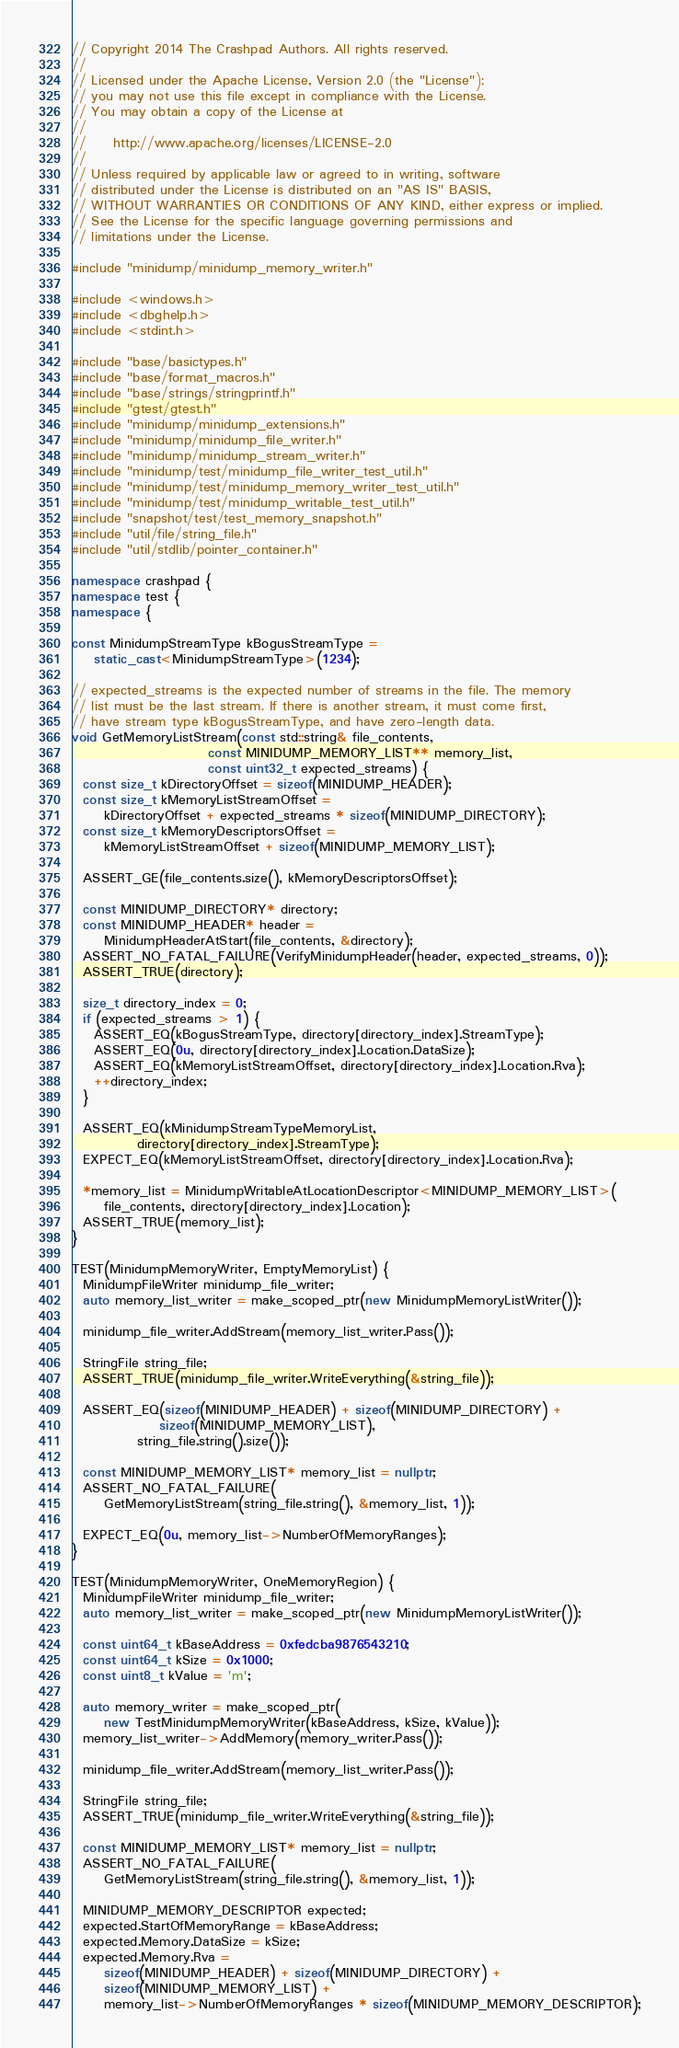Convert code to text. <code><loc_0><loc_0><loc_500><loc_500><_C++_>// Copyright 2014 The Crashpad Authors. All rights reserved.
//
// Licensed under the Apache License, Version 2.0 (the "License");
// you may not use this file except in compliance with the License.
// You may obtain a copy of the License at
//
//     http://www.apache.org/licenses/LICENSE-2.0
//
// Unless required by applicable law or agreed to in writing, software
// distributed under the License is distributed on an "AS IS" BASIS,
// WITHOUT WARRANTIES OR CONDITIONS OF ANY KIND, either express or implied.
// See the License for the specific language governing permissions and
// limitations under the License.

#include "minidump/minidump_memory_writer.h"

#include <windows.h>
#include <dbghelp.h>
#include <stdint.h>

#include "base/basictypes.h"
#include "base/format_macros.h"
#include "base/strings/stringprintf.h"
#include "gtest/gtest.h"
#include "minidump/minidump_extensions.h"
#include "minidump/minidump_file_writer.h"
#include "minidump/minidump_stream_writer.h"
#include "minidump/test/minidump_file_writer_test_util.h"
#include "minidump/test/minidump_memory_writer_test_util.h"
#include "minidump/test/minidump_writable_test_util.h"
#include "snapshot/test/test_memory_snapshot.h"
#include "util/file/string_file.h"
#include "util/stdlib/pointer_container.h"

namespace crashpad {
namespace test {
namespace {

const MinidumpStreamType kBogusStreamType =
    static_cast<MinidumpStreamType>(1234);

// expected_streams is the expected number of streams in the file. The memory
// list must be the last stream. If there is another stream, it must come first,
// have stream type kBogusStreamType, and have zero-length data.
void GetMemoryListStream(const std::string& file_contents,
                         const MINIDUMP_MEMORY_LIST** memory_list,
                         const uint32_t expected_streams) {
  const size_t kDirectoryOffset = sizeof(MINIDUMP_HEADER);
  const size_t kMemoryListStreamOffset =
      kDirectoryOffset + expected_streams * sizeof(MINIDUMP_DIRECTORY);
  const size_t kMemoryDescriptorsOffset =
      kMemoryListStreamOffset + sizeof(MINIDUMP_MEMORY_LIST);

  ASSERT_GE(file_contents.size(), kMemoryDescriptorsOffset);

  const MINIDUMP_DIRECTORY* directory;
  const MINIDUMP_HEADER* header =
      MinidumpHeaderAtStart(file_contents, &directory);
  ASSERT_NO_FATAL_FAILURE(VerifyMinidumpHeader(header, expected_streams, 0));
  ASSERT_TRUE(directory);

  size_t directory_index = 0;
  if (expected_streams > 1) {
    ASSERT_EQ(kBogusStreamType, directory[directory_index].StreamType);
    ASSERT_EQ(0u, directory[directory_index].Location.DataSize);
    ASSERT_EQ(kMemoryListStreamOffset, directory[directory_index].Location.Rva);
    ++directory_index;
  }

  ASSERT_EQ(kMinidumpStreamTypeMemoryList,
            directory[directory_index].StreamType);
  EXPECT_EQ(kMemoryListStreamOffset, directory[directory_index].Location.Rva);

  *memory_list = MinidumpWritableAtLocationDescriptor<MINIDUMP_MEMORY_LIST>(
      file_contents, directory[directory_index].Location);
  ASSERT_TRUE(memory_list);
}

TEST(MinidumpMemoryWriter, EmptyMemoryList) {
  MinidumpFileWriter minidump_file_writer;
  auto memory_list_writer = make_scoped_ptr(new MinidumpMemoryListWriter());

  minidump_file_writer.AddStream(memory_list_writer.Pass());

  StringFile string_file;
  ASSERT_TRUE(minidump_file_writer.WriteEverything(&string_file));

  ASSERT_EQ(sizeof(MINIDUMP_HEADER) + sizeof(MINIDUMP_DIRECTORY) +
                sizeof(MINIDUMP_MEMORY_LIST),
            string_file.string().size());

  const MINIDUMP_MEMORY_LIST* memory_list = nullptr;
  ASSERT_NO_FATAL_FAILURE(
      GetMemoryListStream(string_file.string(), &memory_list, 1));

  EXPECT_EQ(0u, memory_list->NumberOfMemoryRanges);
}

TEST(MinidumpMemoryWriter, OneMemoryRegion) {
  MinidumpFileWriter minidump_file_writer;
  auto memory_list_writer = make_scoped_ptr(new MinidumpMemoryListWriter());

  const uint64_t kBaseAddress = 0xfedcba9876543210;
  const uint64_t kSize = 0x1000;
  const uint8_t kValue = 'm';

  auto memory_writer = make_scoped_ptr(
      new TestMinidumpMemoryWriter(kBaseAddress, kSize, kValue));
  memory_list_writer->AddMemory(memory_writer.Pass());

  minidump_file_writer.AddStream(memory_list_writer.Pass());

  StringFile string_file;
  ASSERT_TRUE(minidump_file_writer.WriteEverything(&string_file));

  const MINIDUMP_MEMORY_LIST* memory_list = nullptr;
  ASSERT_NO_FATAL_FAILURE(
      GetMemoryListStream(string_file.string(), &memory_list, 1));

  MINIDUMP_MEMORY_DESCRIPTOR expected;
  expected.StartOfMemoryRange = kBaseAddress;
  expected.Memory.DataSize = kSize;
  expected.Memory.Rva =
      sizeof(MINIDUMP_HEADER) + sizeof(MINIDUMP_DIRECTORY) +
      sizeof(MINIDUMP_MEMORY_LIST) +
      memory_list->NumberOfMemoryRanges * sizeof(MINIDUMP_MEMORY_DESCRIPTOR);</code> 